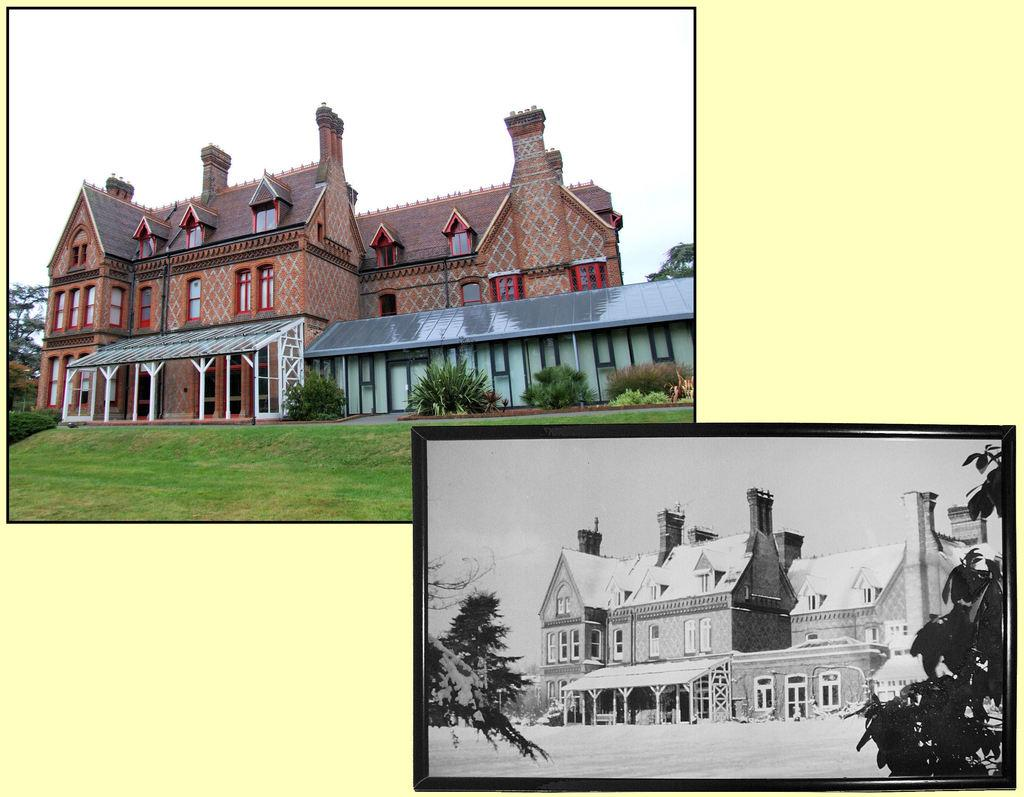What type of artwork is the image? The image is a collage. What type of structures can be seen in the image? There are buildings in the image. What type of vegetation is present in the image? There is grass, plants, and trees in the image. What part of the natural environment is visible in the image? The sky is visible in the image. What time of day does the grandmother express her disgust in the image? There is no grandmother or expression of disgust present in the image. 